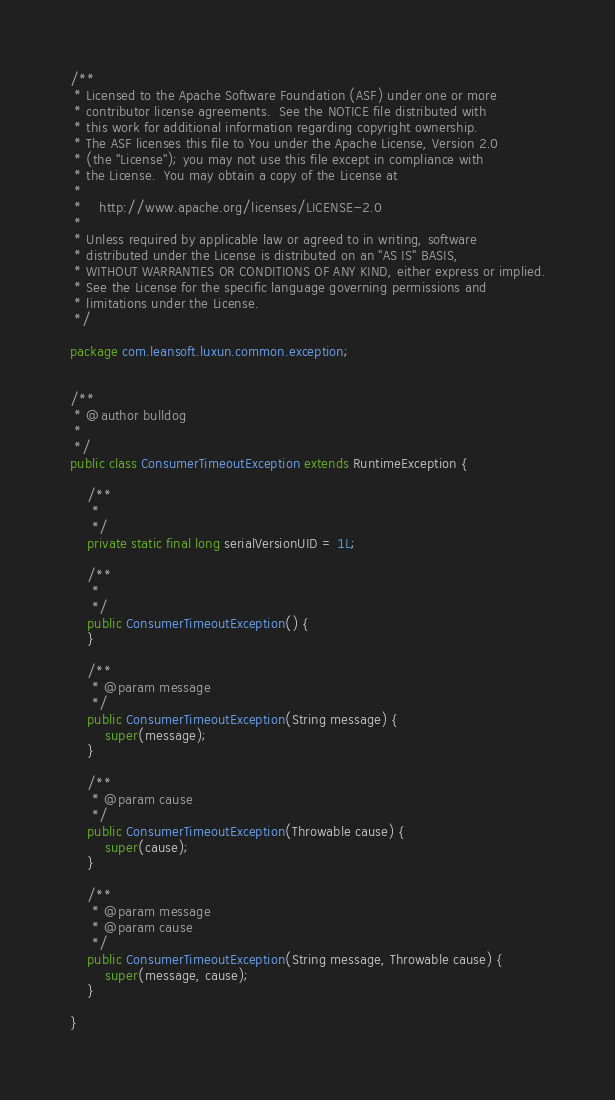Convert code to text. <code><loc_0><loc_0><loc_500><loc_500><_Java_>/**
 * Licensed to the Apache Software Foundation (ASF) under one or more
 * contributor license agreements.  See the NOTICE file distributed with
 * this work for additional information regarding copyright ownership.
 * The ASF licenses this file to You under the Apache License, Version 2.0
 * (the "License"); you may not use this file except in compliance with
 * the License.  You may obtain a copy of the License at
 * 
 *    http://www.apache.org/licenses/LICENSE-2.0
 *
 * Unless required by applicable law or agreed to in writing, software
 * distributed under the License is distributed on an "AS IS" BASIS,
 * WITHOUT WARRANTIES OR CONDITIONS OF ANY KIND, either express or implied.
 * See the License for the specific language governing permissions and
 * limitations under the License.
 */

package com.leansoft.luxun.common.exception;


/**
 * @author bulldog
 * 
 */
public class ConsumerTimeoutException extends RuntimeException {

    /**
     * 
     */
    private static final long serialVersionUID = 1L;

    /**
     * 
     */
    public ConsumerTimeoutException() {
    }

    /**
     * @param message
     */
    public ConsumerTimeoutException(String message) {
        super(message);
    }

    /**
     * @param cause
     */
    public ConsumerTimeoutException(Throwable cause) {
        super(cause);
    }

    /**
     * @param message
     * @param cause
     */
    public ConsumerTimeoutException(String message, Throwable cause) {
        super(message, cause);
    }

}
</code> 